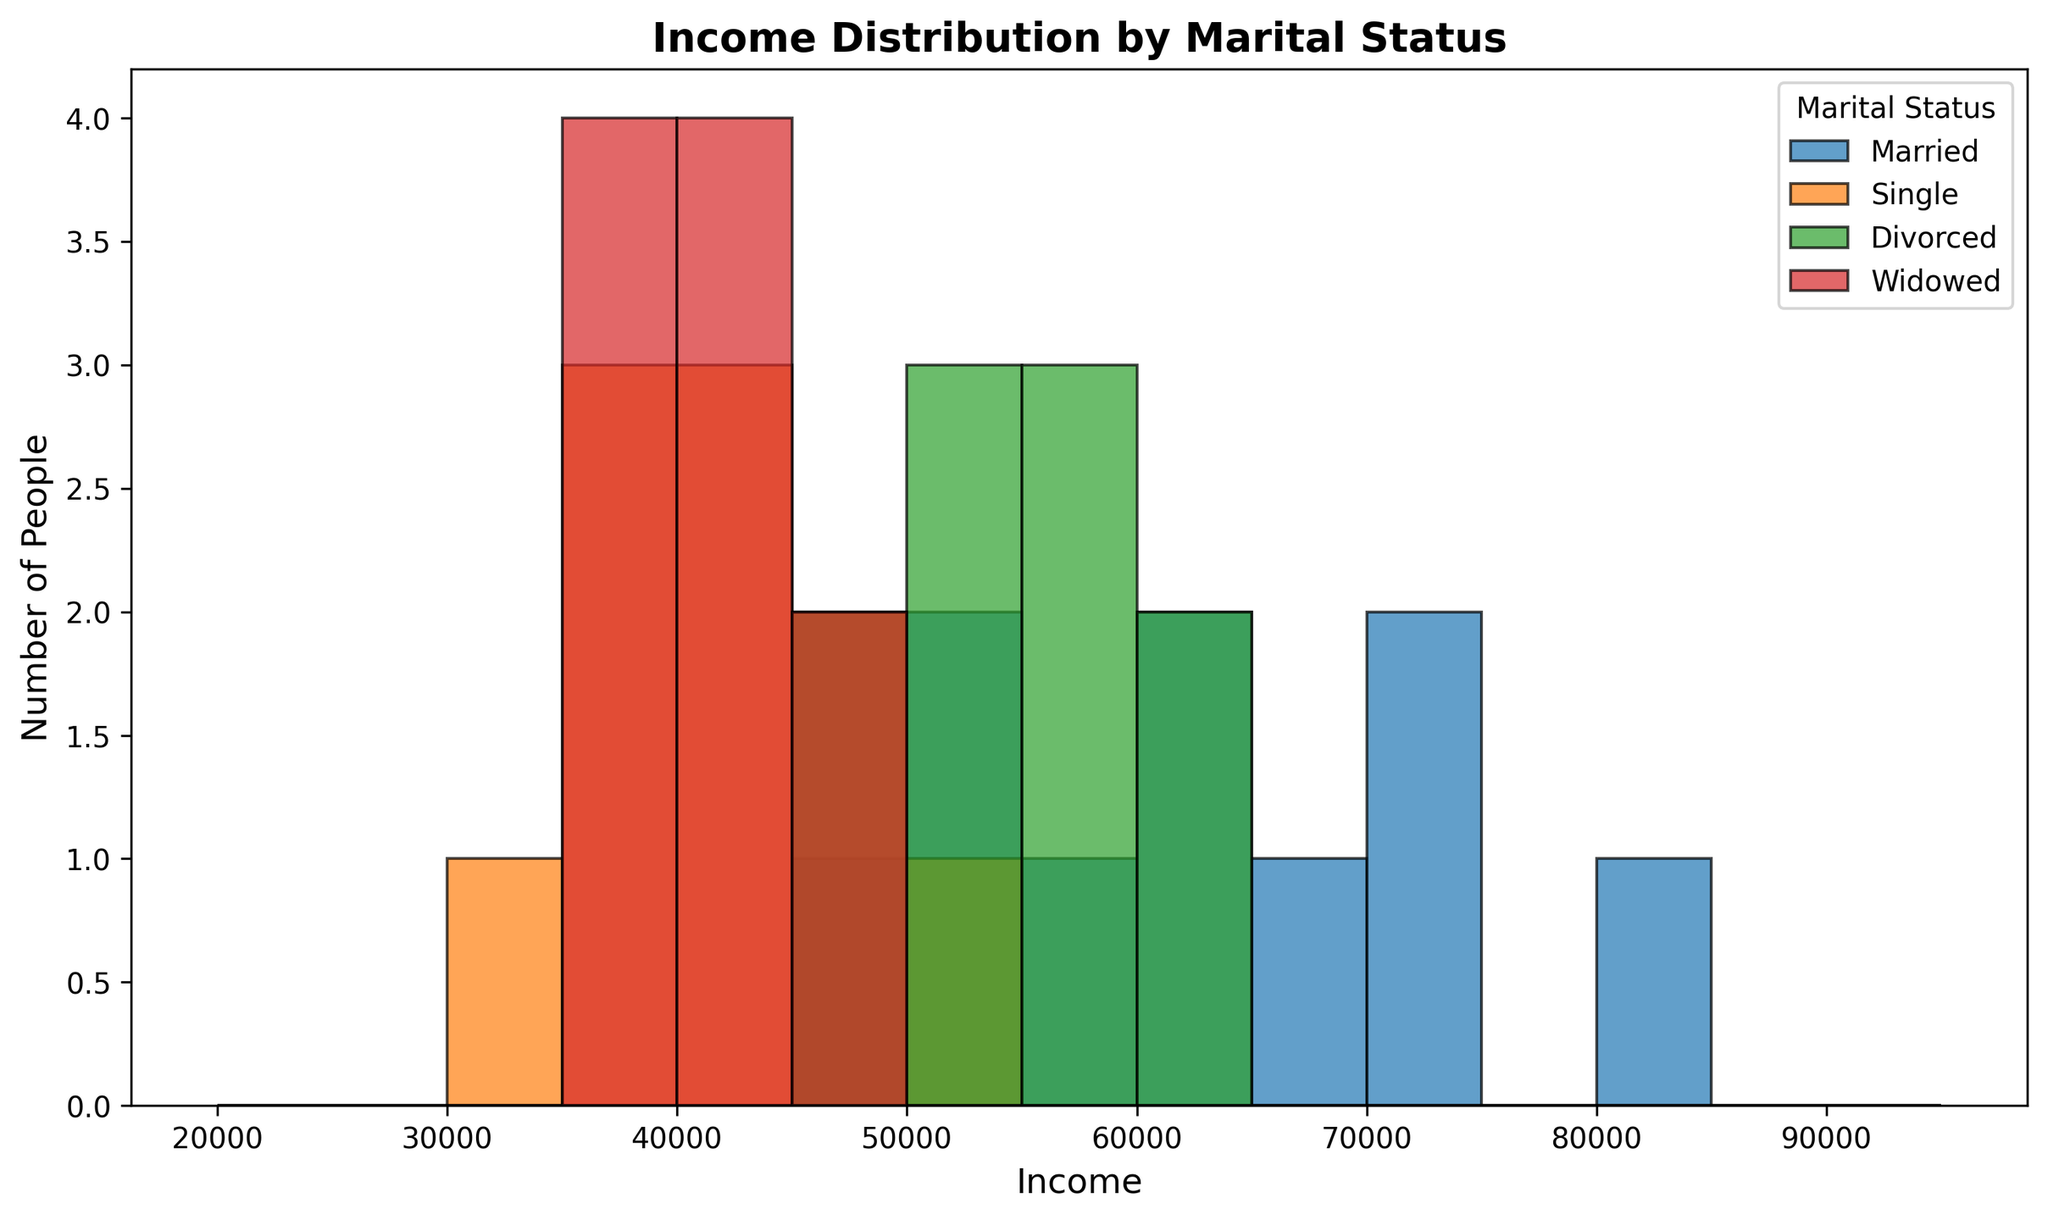What is the most common income range for married individuals? Based on the figure's histogram bars, identify the tallest bar in the section representing married individuals. The height of the tallest bar shows the most common income range.
Answer: $60,000 - $65,000 Which marital status group has the highest peak in the histogram? Compare the heights of the tallest bars across different marital status groups. The one with the highest peak represents the group with the highest peak in the histogram.
Answer: Married What is the income range where most single individuals fall? Observe the histogram section for single individuals and identify the tallest bar, which indicates the most common income range.
Answer: $40,000 - $45,000 Between divorced and widowed individuals, which group has a more evenly spread income distribution? Compare the distribution of bars, observing the consistency in bar heights for divorced and widowed sections. More evenly distributed bars indicate a more uniform spread.
Answer: Divorced Which income range has the least representation across all marital statuses? Identify the income range with the shortest bar or bars in the histogram, considering all marital status groups. The shortest bar indicates the least representation.
Answer: $95,000 - $100,000 In which income range do both single and widowed individuals have similar numbers? Compare the heights of bars for single and widowed individuals, looking for bars of similar height within the same income range.
Answer: $40,000 - $45,000 Which marital status group has the smallest number of people earning below $40,000? Count and compare the heights of bars below the $40,000 income range for each marital status group. The group with the shortest bars or no bars represents the smallest number.
Answer: Married What is the income range with the largest difference in the number of people between married and divorced individuals? Calculate the difference in bar heights between married and divorced individuals for each income range and identify the range with the maximum difference.
Answer: $70,000 - $75,000 In which income range do divorced individuals have the majority compared to other groups? Evaluate the height of bars for divorced individuals across all income ranges, and identify the range where their bar is the tallest compared to other groups.
Answer: $60,000 - $65,000 Which income range has significant representation from all marital status groups? Look for income ranges where multiple or all marital status groups have bars of noticeable height, indicating significant representation.
Answer: $40,000 - $45,000 